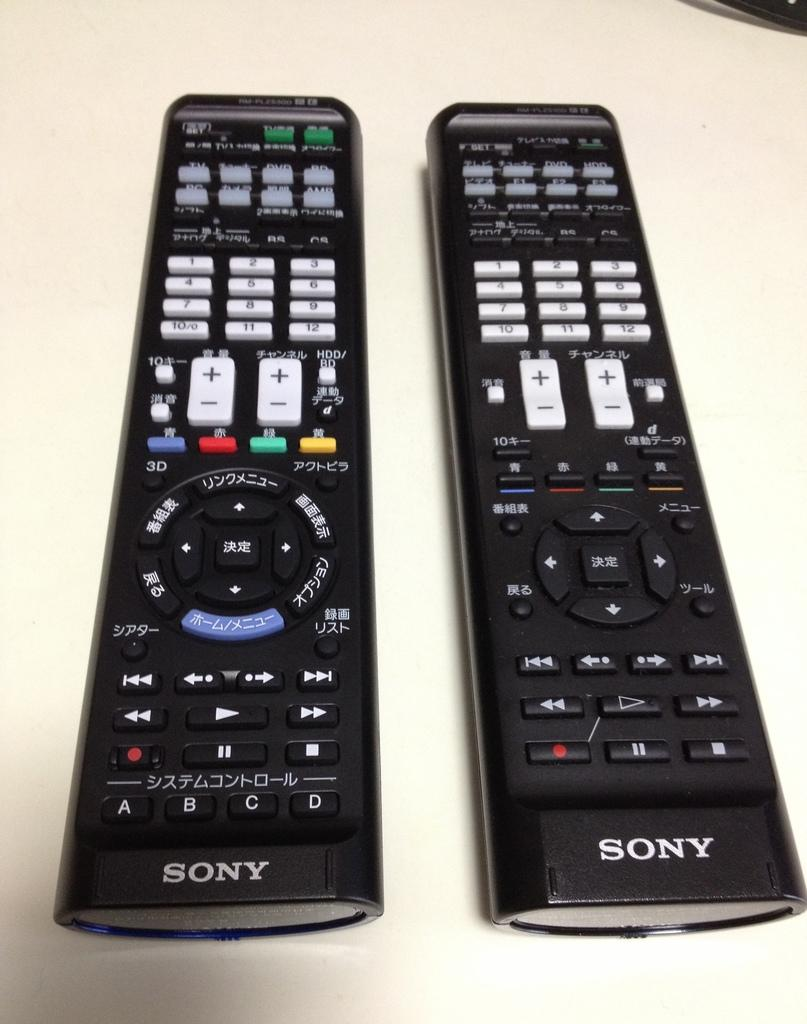<image>
Give a short and clear explanation of the subsequent image. Two remote controllers next to one another with the brand SONY on the bottom. 